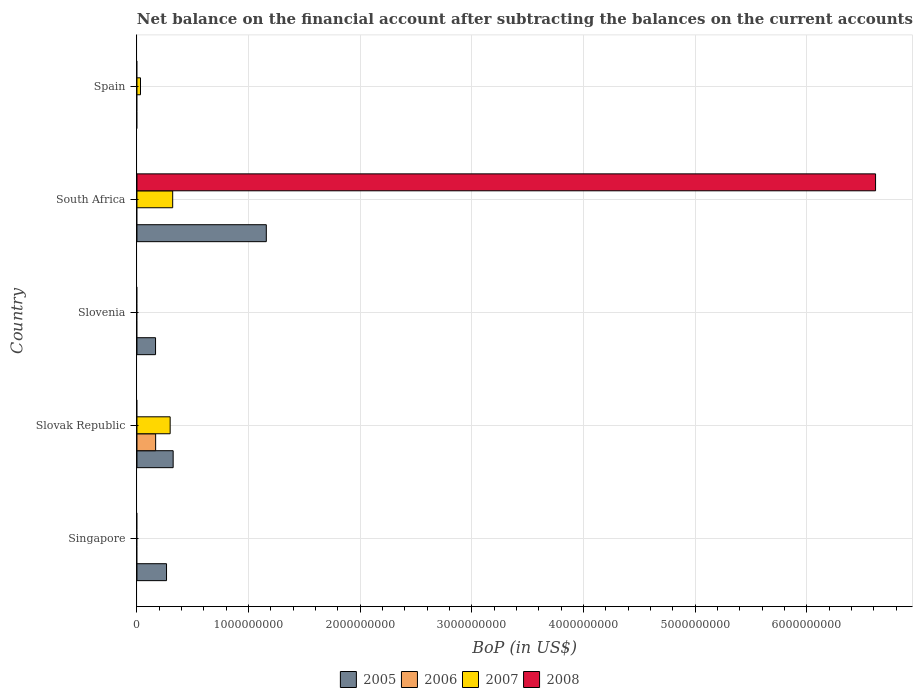How many different coloured bars are there?
Provide a succinct answer. 4. Are the number of bars per tick equal to the number of legend labels?
Offer a terse response. No. Are the number of bars on each tick of the Y-axis equal?
Offer a terse response. No. What is the label of the 2nd group of bars from the top?
Your answer should be compact. South Africa. What is the Balance of Payments in 2005 in Slovenia?
Make the answer very short. 1.66e+08. Across all countries, what is the maximum Balance of Payments in 2005?
Your answer should be compact. 1.16e+09. In which country was the Balance of Payments in 2007 maximum?
Offer a terse response. South Africa. What is the total Balance of Payments in 2005 in the graph?
Provide a short and direct response. 1.91e+09. What is the difference between the Balance of Payments in 2005 in Singapore and that in Slovak Republic?
Give a very brief answer. -5.93e+07. What is the difference between the Balance of Payments in 2007 in Slovenia and the Balance of Payments in 2005 in South Africa?
Make the answer very short. -1.16e+09. What is the average Balance of Payments in 2008 per country?
Offer a very short reply. 1.32e+09. What is the difference between the Balance of Payments in 2008 and Balance of Payments in 2007 in South Africa?
Provide a succinct answer. 6.30e+09. What is the ratio of the Balance of Payments in 2005 in Singapore to that in South Africa?
Your answer should be very brief. 0.23. What is the difference between the highest and the second highest Balance of Payments in 2007?
Offer a terse response. 2.26e+07. What is the difference between the highest and the lowest Balance of Payments in 2007?
Keep it short and to the point. 3.20e+08. In how many countries, is the Balance of Payments in 2005 greater than the average Balance of Payments in 2005 taken over all countries?
Ensure brevity in your answer.  1. How many bars are there?
Provide a succinct answer. 9. Are all the bars in the graph horizontal?
Keep it short and to the point. Yes. How many countries are there in the graph?
Provide a short and direct response. 5. Are the values on the major ticks of X-axis written in scientific E-notation?
Offer a very short reply. No. Does the graph contain grids?
Your response must be concise. Yes. How are the legend labels stacked?
Provide a short and direct response. Horizontal. What is the title of the graph?
Offer a very short reply. Net balance on the financial account after subtracting the balances on the current accounts. Does "1976" appear as one of the legend labels in the graph?
Your answer should be compact. No. What is the label or title of the X-axis?
Make the answer very short. BoP (in US$). What is the BoP (in US$) in 2005 in Singapore?
Give a very brief answer. 2.65e+08. What is the BoP (in US$) of 2006 in Singapore?
Offer a very short reply. 0. What is the BoP (in US$) of 2008 in Singapore?
Give a very brief answer. 0. What is the BoP (in US$) of 2005 in Slovak Republic?
Make the answer very short. 3.24e+08. What is the BoP (in US$) of 2006 in Slovak Republic?
Provide a short and direct response. 1.67e+08. What is the BoP (in US$) of 2007 in Slovak Republic?
Offer a very short reply. 2.97e+08. What is the BoP (in US$) in 2008 in Slovak Republic?
Make the answer very short. 0. What is the BoP (in US$) in 2005 in Slovenia?
Give a very brief answer. 1.66e+08. What is the BoP (in US$) in 2008 in Slovenia?
Your answer should be compact. 0. What is the BoP (in US$) of 2005 in South Africa?
Provide a succinct answer. 1.16e+09. What is the BoP (in US$) in 2006 in South Africa?
Your response must be concise. 0. What is the BoP (in US$) in 2007 in South Africa?
Your answer should be very brief. 3.20e+08. What is the BoP (in US$) in 2008 in South Africa?
Offer a very short reply. 6.62e+09. What is the BoP (in US$) in 2005 in Spain?
Make the answer very short. 0. What is the BoP (in US$) of 2007 in Spain?
Offer a terse response. 3.16e+07. Across all countries, what is the maximum BoP (in US$) of 2005?
Your response must be concise. 1.16e+09. Across all countries, what is the maximum BoP (in US$) of 2006?
Your response must be concise. 1.67e+08. Across all countries, what is the maximum BoP (in US$) of 2007?
Your answer should be very brief. 3.20e+08. Across all countries, what is the maximum BoP (in US$) of 2008?
Your answer should be very brief. 6.62e+09. Across all countries, what is the minimum BoP (in US$) in 2006?
Your answer should be very brief. 0. What is the total BoP (in US$) in 2005 in the graph?
Your answer should be very brief. 1.91e+09. What is the total BoP (in US$) of 2006 in the graph?
Your answer should be compact. 1.67e+08. What is the total BoP (in US$) in 2007 in the graph?
Offer a very short reply. 6.49e+08. What is the total BoP (in US$) in 2008 in the graph?
Provide a short and direct response. 6.62e+09. What is the difference between the BoP (in US$) of 2005 in Singapore and that in Slovak Republic?
Give a very brief answer. -5.93e+07. What is the difference between the BoP (in US$) of 2005 in Singapore and that in Slovenia?
Keep it short and to the point. 9.85e+07. What is the difference between the BoP (in US$) in 2005 in Singapore and that in South Africa?
Provide a succinct answer. -8.94e+08. What is the difference between the BoP (in US$) of 2005 in Slovak Republic and that in Slovenia?
Your response must be concise. 1.58e+08. What is the difference between the BoP (in US$) in 2005 in Slovak Republic and that in South Africa?
Offer a very short reply. -8.34e+08. What is the difference between the BoP (in US$) of 2007 in Slovak Republic and that in South Africa?
Offer a very short reply. -2.26e+07. What is the difference between the BoP (in US$) in 2007 in Slovak Republic and that in Spain?
Provide a short and direct response. 2.66e+08. What is the difference between the BoP (in US$) in 2005 in Slovenia and that in South Africa?
Provide a short and direct response. -9.92e+08. What is the difference between the BoP (in US$) of 2007 in South Africa and that in Spain?
Ensure brevity in your answer.  2.88e+08. What is the difference between the BoP (in US$) in 2005 in Singapore and the BoP (in US$) in 2006 in Slovak Republic?
Keep it short and to the point. 9.76e+07. What is the difference between the BoP (in US$) in 2005 in Singapore and the BoP (in US$) in 2007 in Slovak Republic?
Ensure brevity in your answer.  -3.24e+07. What is the difference between the BoP (in US$) in 2005 in Singapore and the BoP (in US$) in 2007 in South Africa?
Give a very brief answer. -5.51e+07. What is the difference between the BoP (in US$) of 2005 in Singapore and the BoP (in US$) of 2008 in South Africa?
Provide a succinct answer. -6.35e+09. What is the difference between the BoP (in US$) in 2005 in Singapore and the BoP (in US$) in 2007 in Spain?
Ensure brevity in your answer.  2.33e+08. What is the difference between the BoP (in US$) of 2005 in Slovak Republic and the BoP (in US$) of 2007 in South Africa?
Ensure brevity in your answer.  4.26e+06. What is the difference between the BoP (in US$) in 2005 in Slovak Republic and the BoP (in US$) in 2008 in South Africa?
Your answer should be compact. -6.29e+09. What is the difference between the BoP (in US$) in 2006 in Slovak Republic and the BoP (in US$) in 2007 in South Africa?
Offer a terse response. -1.53e+08. What is the difference between the BoP (in US$) of 2006 in Slovak Republic and the BoP (in US$) of 2008 in South Africa?
Offer a terse response. -6.45e+09. What is the difference between the BoP (in US$) of 2007 in Slovak Republic and the BoP (in US$) of 2008 in South Africa?
Your answer should be compact. -6.32e+09. What is the difference between the BoP (in US$) of 2005 in Slovak Republic and the BoP (in US$) of 2007 in Spain?
Provide a succinct answer. 2.93e+08. What is the difference between the BoP (in US$) in 2006 in Slovak Republic and the BoP (in US$) in 2007 in Spain?
Your response must be concise. 1.36e+08. What is the difference between the BoP (in US$) of 2005 in Slovenia and the BoP (in US$) of 2007 in South Africa?
Your answer should be compact. -1.54e+08. What is the difference between the BoP (in US$) of 2005 in Slovenia and the BoP (in US$) of 2008 in South Africa?
Provide a succinct answer. -6.45e+09. What is the difference between the BoP (in US$) in 2005 in Slovenia and the BoP (in US$) in 2007 in Spain?
Offer a terse response. 1.35e+08. What is the difference between the BoP (in US$) in 2005 in South Africa and the BoP (in US$) in 2007 in Spain?
Give a very brief answer. 1.13e+09. What is the average BoP (in US$) of 2005 per country?
Make the answer very short. 3.83e+08. What is the average BoP (in US$) in 2006 per country?
Provide a short and direct response. 3.35e+07. What is the average BoP (in US$) of 2007 per country?
Provide a succinct answer. 1.30e+08. What is the average BoP (in US$) in 2008 per country?
Make the answer very short. 1.32e+09. What is the difference between the BoP (in US$) of 2005 and BoP (in US$) of 2006 in Slovak Republic?
Offer a very short reply. 1.57e+08. What is the difference between the BoP (in US$) in 2005 and BoP (in US$) in 2007 in Slovak Republic?
Your response must be concise. 2.69e+07. What is the difference between the BoP (in US$) in 2006 and BoP (in US$) in 2007 in Slovak Republic?
Your response must be concise. -1.30e+08. What is the difference between the BoP (in US$) in 2005 and BoP (in US$) in 2007 in South Africa?
Your answer should be very brief. 8.39e+08. What is the difference between the BoP (in US$) of 2005 and BoP (in US$) of 2008 in South Africa?
Offer a very short reply. -5.46e+09. What is the difference between the BoP (in US$) of 2007 and BoP (in US$) of 2008 in South Africa?
Give a very brief answer. -6.30e+09. What is the ratio of the BoP (in US$) of 2005 in Singapore to that in Slovak Republic?
Give a very brief answer. 0.82. What is the ratio of the BoP (in US$) in 2005 in Singapore to that in Slovenia?
Provide a short and direct response. 1.59. What is the ratio of the BoP (in US$) in 2005 in Singapore to that in South Africa?
Keep it short and to the point. 0.23. What is the ratio of the BoP (in US$) in 2005 in Slovak Republic to that in Slovenia?
Make the answer very short. 1.95. What is the ratio of the BoP (in US$) in 2005 in Slovak Republic to that in South Africa?
Offer a terse response. 0.28. What is the ratio of the BoP (in US$) of 2007 in Slovak Republic to that in South Africa?
Offer a terse response. 0.93. What is the ratio of the BoP (in US$) in 2007 in Slovak Republic to that in Spain?
Offer a terse response. 9.4. What is the ratio of the BoP (in US$) in 2005 in Slovenia to that in South Africa?
Offer a very short reply. 0.14. What is the ratio of the BoP (in US$) in 2007 in South Africa to that in Spain?
Offer a very short reply. 10.11. What is the difference between the highest and the second highest BoP (in US$) of 2005?
Ensure brevity in your answer.  8.34e+08. What is the difference between the highest and the second highest BoP (in US$) in 2007?
Make the answer very short. 2.26e+07. What is the difference between the highest and the lowest BoP (in US$) in 2005?
Give a very brief answer. 1.16e+09. What is the difference between the highest and the lowest BoP (in US$) in 2006?
Give a very brief answer. 1.67e+08. What is the difference between the highest and the lowest BoP (in US$) of 2007?
Provide a short and direct response. 3.20e+08. What is the difference between the highest and the lowest BoP (in US$) of 2008?
Ensure brevity in your answer.  6.62e+09. 